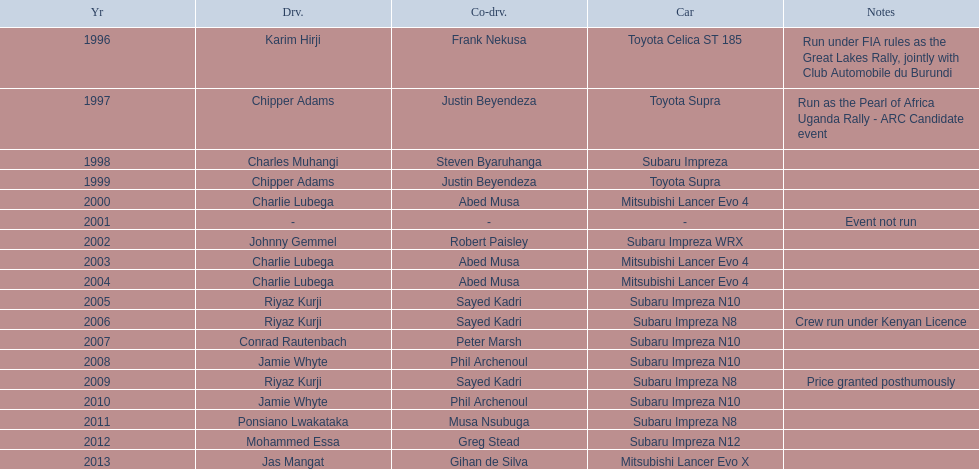Who is the only driver to have consecutive wins? Charlie Lubega. 